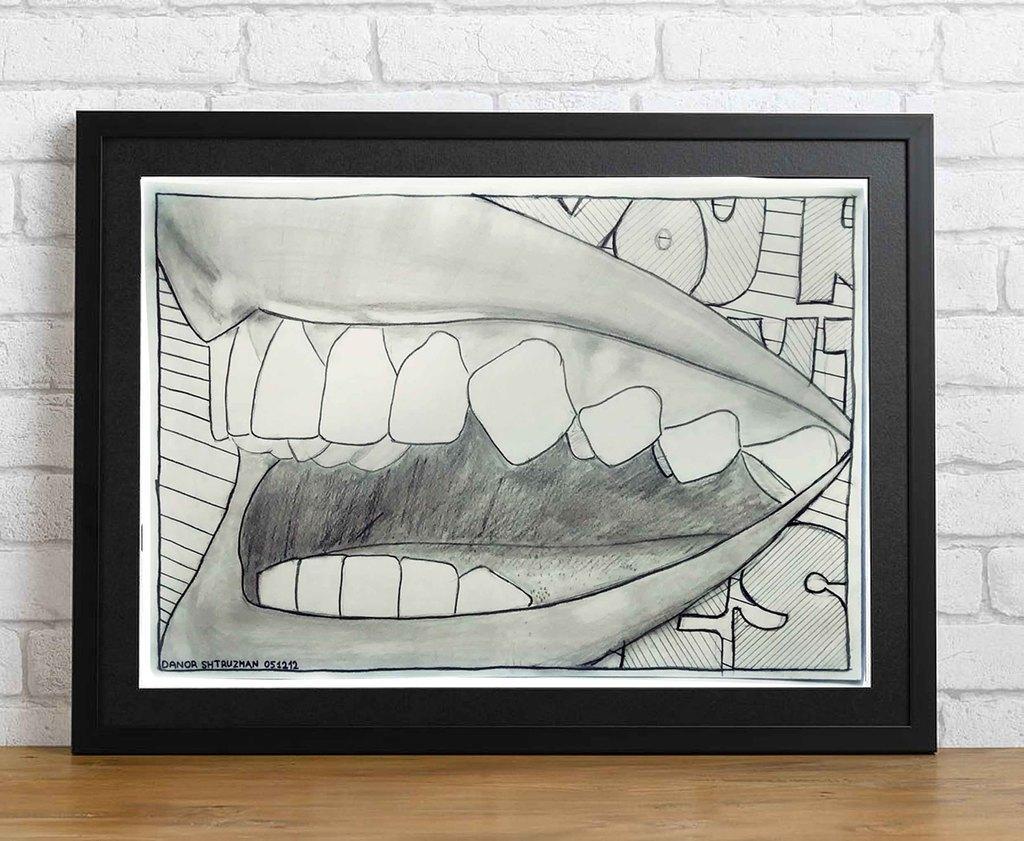Can you describe this image briefly? In the image we can see there is a photo frame kept on the table and there is a drawing of human mouth. The drawing in the photo frame is in black and white colour. Behind there is a white colour wall. 